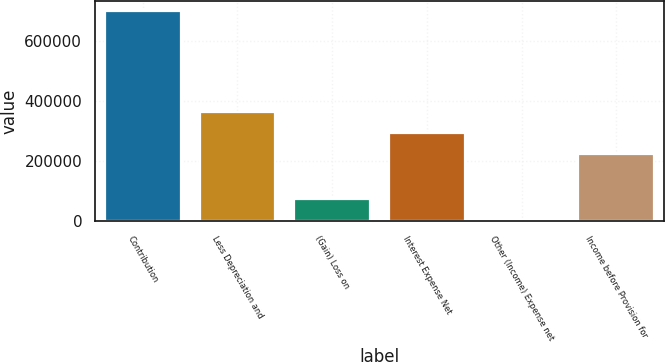<chart> <loc_0><loc_0><loc_500><loc_500><bar_chart><fcel>Contribution<fcel>Less Depreciation and<fcel>(Gain) Loss on<fcel>Interest Expense Net<fcel>Other (Income) Expense net<fcel>Income before Provision for<nl><fcel>698540<fcel>362112<fcel>72644.9<fcel>292568<fcel>3101<fcel>223024<nl></chart> 